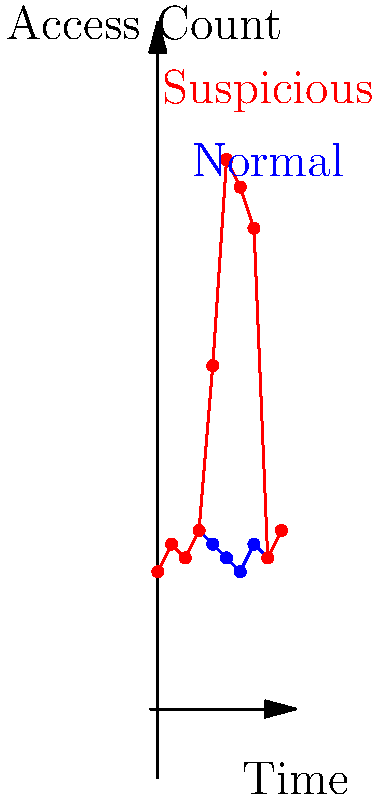As a news reporter investigating a recent security breach, you've obtained a visual representation of log file data. The blue line represents normal access patterns, while the red line shows a potentially suspicious pattern. What time frame (in hours) shows the most significant deviation from normal activity, potentially indicating the breach? To identify the most significant deviation from normal activity:

1. Examine both lines (blue for normal, red for suspicious) across the time axis.
2. Look for areas where the red line diverges significantly from the blue line.
3. The most notable divergence occurs between hours 4 and 7.
4. At hour 4, both lines are close (around 13 accesses).
5. At hour 5, the red line spikes dramatically to about 25 accesses, while the blue line remains around 11-12.
6. The red line peaks at hour 6 with about 40 accesses, far above the normal 10-11.
7. At hour 7, the red line is still elevated at about 35 accesses, while normal remains around 12.
8. By hour 8, the red line returns to normal levels.

The most significant deviation occurs in the 3-hour period from hour 5 to hour 7, inclusive.
Answer: 5-7 